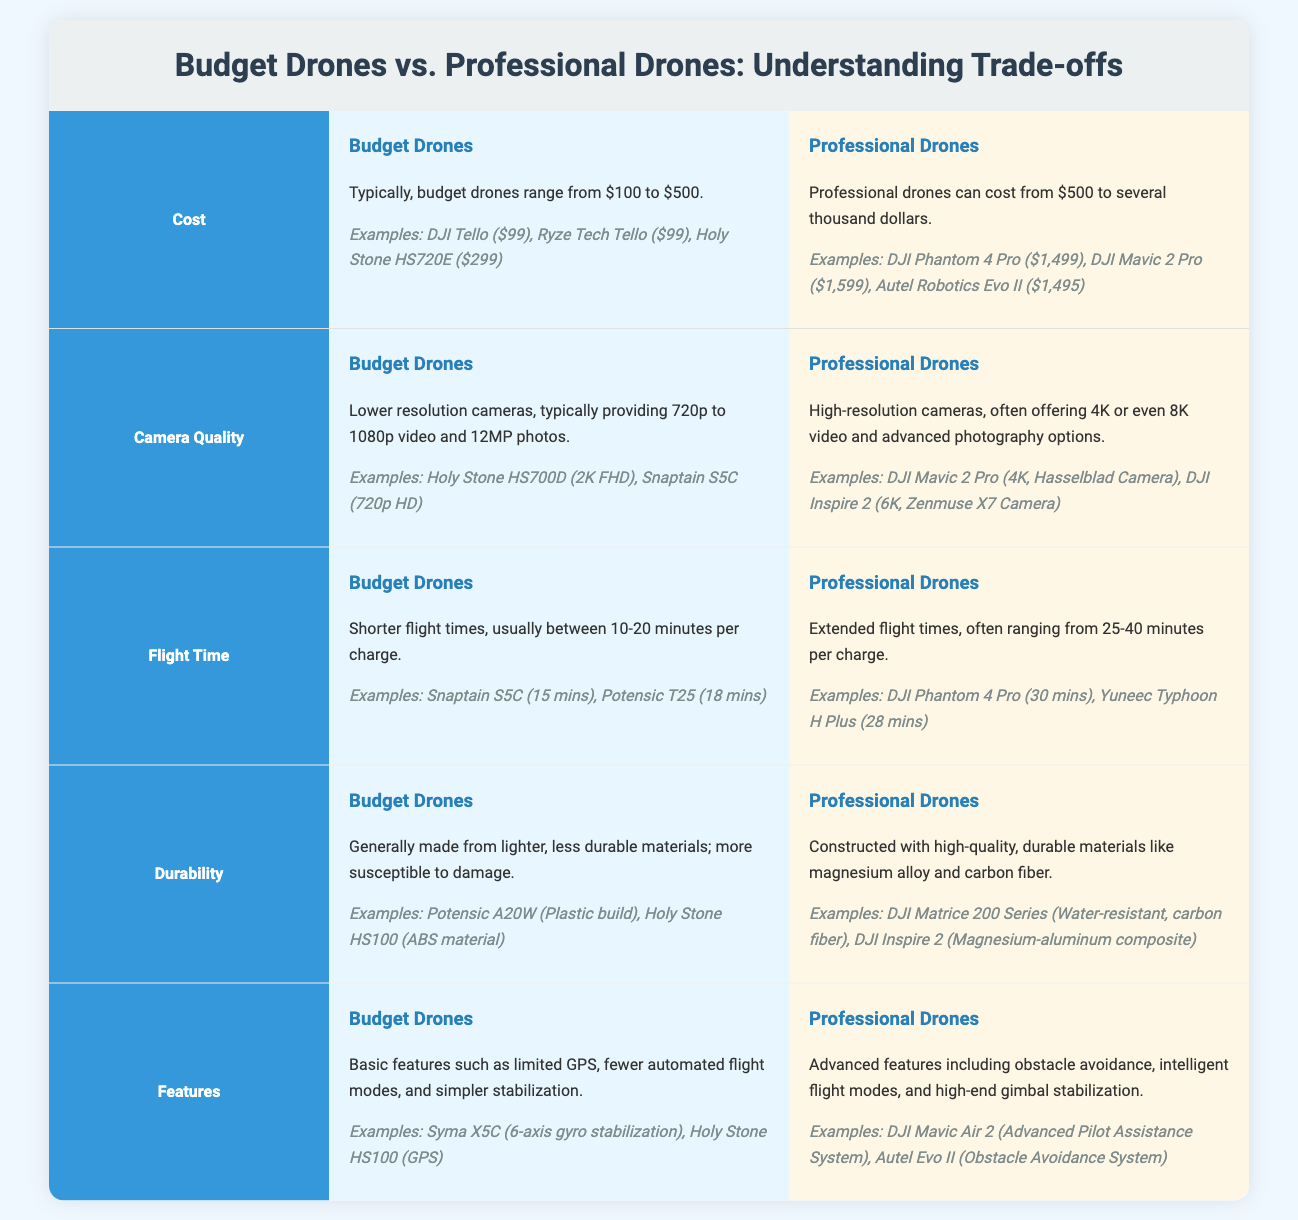what is the price range for budget drones? Budget drones typically range from $100 to $500 according to the comparison infographic.
Answer: $100 to $500 what is an example of a professional drone? An example of a professional drone mentioned in the document is the DJI Phantom 4 Pro.
Answer: DJI Phantom 4 Pro what is the flight time range for budget drones? Budget drones have flight times typically between 10-20 minutes per charge.
Answer: 10-20 minutes which type of drone generally has higher camera resolution? The comparison states that professional drones offer high-resolution cameras, indicating superior image quality.
Answer: Professional drones how long is the flight time for the DJI Phantom 4 Pro? The document states that the flight time for the DJI Phantom 4 Pro is 30 minutes.
Answer: 30 minutes what materials are professional drones made from? Professional drones are constructed with high-quality, durable materials like magnesium alloy and carbon fiber.
Answer: Magnesium alloy and carbon fiber what features do budget drones typically have? Budget drones generally come with basic features such as limited GPS and fewer automated flight modes.
Answer: Basic features what is a common durability issue with budget drones? Budget drones are generally made from lighter, less durable materials, making them more susceptible to damage.
Answer: Susceptible to damage which professional drone offers advanced obstacle avoidance? The Autel Evo II is cited in the infographic as offering an obstacle avoidance system.
Answer: Autel Evo II 